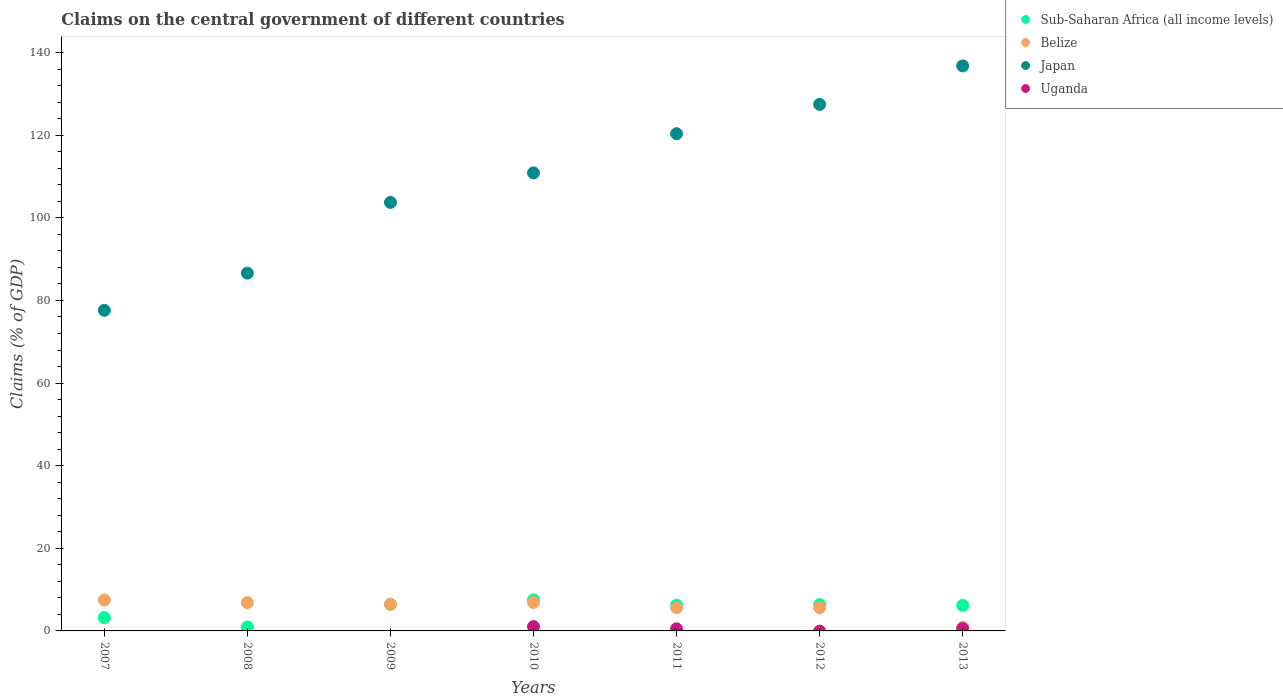How many different coloured dotlines are there?
Provide a succinct answer. 4. Is the number of dotlines equal to the number of legend labels?
Make the answer very short. No. What is the percentage of GDP claimed on the central government in Uganda in 2007?
Ensure brevity in your answer.  0. Across all years, what is the maximum percentage of GDP claimed on the central government in Sub-Saharan Africa (all income levels)?
Offer a terse response. 7.52. Across all years, what is the minimum percentage of GDP claimed on the central government in Japan?
Offer a very short reply. 77.62. What is the total percentage of GDP claimed on the central government in Sub-Saharan Africa (all income levels) in the graph?
Your answer should be very brief. 36.92. What is the difference between the percentage of GDP claimed on the central government in Belize in 2008 and that in 2011?
Provide a succinct answer. 1.26. What is the difference between the percentage of GDP claimed on the central government in Japan in 2008 and the percentage of GDP claimed on the central government in Belize in 2012?
Provide a succinct answer. 80.99. What is the average percentage of GDP claimed on the central government in Japan per year?
Keep it short and to the point. 109.07. In the year 2009, what is the difference between the percentage of GDP claimed on the central government in Japan and percentage of GDP claimed on the central government in Belize?
Offer a terse response. 97.32. In how many years, is the percentage of GDP claimed on the central government in Sub-Saharan Africa (all income levels) greater than 104 %?
Offer a terse response. 0. What is the ratio of the percentage of GDP claimed on the central government in Japan in 2007 to that in 2010?
Ensure brevity in your answer.  0.7. Is the difference between the percentage of GDP claimed on the central government in Japan in 2010 and 2012 greater than the difference between the percentage of GDP claimed on the central government in Belize in 2010 and 2012?
Make the answer very short. No. What is the difference between the highest and the second highest percentage of GDP claimed on the central government in Sub-Saharan Africa (all income levels)?
Offer a terse response. 1.07. What is the difference between the highest and the lowest percentage of GDP claimed on the central government in Uganda?
Provide a short and direct response. 1.07. Is the sum of the percentage of GDP claimed on the central government in Belize in 2009 and 2013 greater than the maximum percentage of GDP claimed on the central government in Sub-Saharan Africa (all income levels) across all years?
Keep it short and to the point. No. Is it the case that in every year, the sum of the percentage of GDP claimed on the central government in Belize and percentage of GDP claimed on the central government in Uganda  is greater than the percentage of GDP claimed on the central government in Sub-Saharan Africa (all income levels)?
Offer a terse response. No. Is the percentage of GDP claimed on the central government in Belize strictly greater than the percentage of GDP claimed on the central government in Sub-Saharan Africa (all income levels) over the years?
Provide a succinct answer. No. Is the percentage of GDP claimed on the central government in Belize strictly less than the percentage of GDP claimed on the central government in Sub-Saharan Africa (all income levels) over the years?
Your response must be concise. No. How many dotlines are there?
Your response must be concise. 4. What is the difference between two consecutive major ticks on the Y-axis?
Provide a succinct answer. 20. Are the values on the major ticks of Y-axis written in scientific E-notation?
Give a very brief answer. No. Where does the legend appear in the graph?
Keep it short and to the point. Top right. How many legend labels are there?
Offer a terse response. 4. What is the title of the graph?
Keep it short and to the point. Claims on the central government of different countries. Does "Moldova" appear as one of the legend labels in the graph?
Make the answer very short. No. What is the label or title of the X-axis?
Provide a short and direct response. Years. What is the label or title of the Y-axis?
Keep it short and to the point. Claims (% of GDP). What is the Claims (% of GDP) in Sub-Saharan Africa (all income levels) in 2007?
Your answer should be very brief. 3.22. What is the Claims (% of GDP) in Belize in 2007?
Give a very brief answer. 7.47. What is the Claims (% of GDP) in Japan in 2007?
Keep it short and to the point. 77.62. What is the Claims (% of GDP) in Sub-Saharan Africa (all income levels) in 2008?
Ensure brevity in your answer.  0.96. What is the Claims (% of GDP) of Belize in 2008?
Provide a short and direct response. 6.86. What is the Claims (% of GDP) in Japan in 2008?
Keep it short and to the point. 86.61. What is the Claims (% of GDP) in Sub-Saharan Africa (all income levels) in 2009?
Ensure brevity in your answer.  6.45. What is the Claims (% of GDP) of Belize in 2009?
Your answer should be compact. 6.42. What is the Claims (% of GDP) of Japan in 2009?
Provide a short and direct response. 103.74. What is the Claims (% of GDP) of Uganda in 2009?
Offer a very short reply. 0. What is the Claims (% of GDP) in Sub-Saharan Africa (all income levels) in 2010?
Your answer should be compact. 7.52. What is the Claims (% of GDP) in Belize in 2010?
Offer a very short reply. 6.9. What is the Claims (% of GDP) in Japan in 2010?
Provide a short and direct response. 110.89. What is the Claims (% of GDP) in Uganda in 2010?
Give a very brief answer. 1.07. What is the Claims (% of GDP) of Sub-Saharan Africa (all income levels) in 2011?
Provide a succinct answer. 6.23. What is the Claims (% of GDP) of Belize in 2011?
Ensure brevity in your answer.  5.6. What is the Claims (% of GDP) in Japan in 2011?
Provide a succinct answer. 120.37. What is the Claims (% of GDP) of Uganda in 2011?
Give a very brief answer. 0.51. What is the Claims (% of GDP) of Sub-Saharan Africa (all income levels) in 2012?
Your answer should be very brief. 6.37. What is the Claims (% of GDP) in Belize in 2012?
Your response must be concise. 5.63. What is the Claims (% of GDP) in Japan in 2012?
Provide a short and direct response. 127.47. What is the Claims (% of GDP) in Sub-Saharan Africa (all income levels) in 2013?
Your response must be concise. 6.17. What is the Claims (% of GDP) in Belize in 2013?
Ensure brevity in your answer.  0.89. What is the Claims (% of GDP) of Japan in 2013?
Keep it short and to the point. 136.79. What is the Claims (% of GDP) of Uganda in 2013?
Offer a very short reply. 0.54. Across all years, what is the maximum Claims (% of GDP) of Sub-Saharan Africa (all income levels)?
Your response must be concise. 7.52. Across all years, what is the maximum Claims (% of GDP) of Belize?
Your answer should be very brief. 7.47. Across all years, what is the maximum Claims (% of GDP) of Japan?
Give a very brief answer. 136.79. Across all years, what is the maximum Claims (% of GDP) of Uganda?
Your answer should be very brief. 1.07. Across all years, what is the minimum Claims (% of GDP) in Sub-Saharan Africa (all income levels)?
Ensure brevity in your answer.  0.96. Across all years, what is the minimum Claims (% of GDP) of Belize?
Your response must be concise. 0.89. Across all years, what is the minimum Claims (% of GDP) of Japan?
Your response must be concise. 77.62. Across all years, what is the minimum Claims (% of GDP) of Uganda?
Your response must be concise. 0. What is the total Claims (% of GDP) in Sub-Saharan Africa (all income levels) in the graph?
Offer a very short reply. 36.92. What is the total Claims (% of GDP) in Belize in the graph?
Offer a terse response. 39.76. What is the total Claims (% of GDP) in Japan in the graph?
Provide a succinct answer. 763.5. What is the total Claims (% of GDP) in Uganda in the graph?
Offer a very short reply. 2.12. What is the difference between the Claims (% of GDP) in Sub-Saharan Africa (all income levels) in 2007 and that in 2008?
Make the answer very short. 2.27. What is the difference between the Claims (% of GDP) in Belize in 2007 and that in 2008?
Make the answer very short. 0.62. What is the difference between the Claims (% of GDP) in Japan in 2007 and that in 2008?
Ensure brevity in your answer.  -8.99. What is the difference between the Claims (% of GDP) in Sub-Saharan Africa (all income levels) in 2007 and that in 2009?
Keep it short and to the point. -3.22. What is the difference between the Claims (% of GDP) of Belize in 2007 and that in 2009?
Your answer should be very brief. 1.06. What is the difference between the Claims (% of GDP) of Japan in 2007 and that in 2009?
Offer a very short reply. -26.12. What is the difference between the Claims (% of GDP) in Sub-Saharan Africa (all income levels) in 2007 and that in 2010?
Your answer should be compact. -4.3. What is the difference between the Claims (% of GDP) of Belize in 2007 and that in 2010?
Provide a short and direct response. 0.58. What is the difference between the Claims (% of GDP) in Japan in 2007 and that in 2010?
Offer a terse response. -33.27. What is the difference between the Claims (% of GDP) of Sub-Saharan Africa (all income levels) in 2007 and that in 2011?
Provide a short and direct response. -3. What is the difference between the Claims (% of GDP) of Belize in 2007 and that in 2011?
Offer a very short reply. 1.88. What is the difference between the Claims (% of GDP) in Japan in 2007 and that in 2011?
Provide a short and direct response. -42.75. What is the difference between the Claims (% of GDP) in Sub-Saharan Africa (all income levels) in 2007 and that in 2012?
Ensure brevity in your answer.  -3.15. What is the difference between the Claims (% of GDP) of Belize in 2007 and that in 2012?
Provide a succinct answer. 1.85. What is the difference between the Claims (% of GDP) of Japan in 2007 and that in 2012?
Offer a very short reply. -49.85. What is the difference between the Claims (% of GDP) in Sub-Saharan Africa (all income levels) in 2007 and that in 2013?
Offer a terse response. -2.94. What is the difference between the Claims (% of GDP) in Belize in 2007 and that in 2013?
Your answer should be compact. 6.59. What is the difference between the Claims (% of GDP) in Japan in 2007 and that in 2013?
Make the answer very short. -59.17. What is the difference between the Claims (% of GDP) of Sub-Saharan Africa (all income levels) in 2008 and that in 2009?
Offer a very short reply. -5.49. What is the difference between the Claims (% of GDP) of Belize in 2008 and that in 2009?
Ensure brevity in your answer.  0.44. What is the difference between the Claims (% of GDP) in Japan in 2008 and that in 2009?
Offer a very short reply. -17.13. What is the difference between the Claims (% of GDP) in Sub-Saharan Africa (all income levels) in 2008 and that in 2010?
Make the answer very short. -6.56. What is the difference between the Claims (% of GDP) in Belize in 2008 and that in 2010?
Your answer should be very brief. -0.04. What is the difference between the Claims (% of GDP) of Japan in 2008 and that in 2010?
Make the answer very short. -24.28. What is the difference between the Claims (% of GDP) in Sub-Saharan Africa (all income levels) in 2008 and that in 2011?
Provide a short and direct response. -5.27. What is the difference between the Claims (% of GDP) in Belize in 2008 and that in 2011?
Your answer should be very brief. 1.26. What is the difference between the Claims (% of GDP) of Japan in 2008 and that in 2011?
Make the answer very short. -33.75. What is the difference between the Claims (% of GDP) in Sub-Saharan Africa (all income levels) in 2008 and that in 2012?
Provide a short and direct response. -5.42. What is the difference between the Claims (% of GDP) of Belize in 2008 and that in 2012?
Your answer should be compact. 1.23. What is the difference between the Claims (% of GDP) in Japan in 2008 and that in 2012?
Keep it short and to the point. -40.86. What is the difference between the Claims (% of GDP) in Sub-Saharan Africa (all income levels) in 2008 and that in 2013?
Make the answer very short. -5.21. What is the difference between the Claims (% of GDP) in Belize in 2008 and that in 2013?
Offer a very short reply. 5.97. What is the difference between the Claims (% of GDP) in Japan in 2008 and that in 2013?
Offer a very short reply. -50.17. What is the difference between the Claims (% of GDP) of Sub-Saharan Africa (all income levels) in 2009 and that in 2010?
Ensure brevity in your answer.  -1.07. What is the difference between the Claims (% of GDP) in Belize in 2009 and that in 2010?
Keep it short and to the point. -0.48. What is the difference between the Claims (% of GDP) in Japan in 2009 and that in 2010?
Your answer should be very brief. -7.15. What is the difference between the Claims (% of GDP) of Sub-Saharan Africa (all income levels) in 2009 and that in 2011?
Your answer should be very brief. 0.22. What is the difference between the Claims (% of GDP) in Belize in 2009 and that in 2011?
Offer a terse response. 0.82. What is the difference between the Claims (% of GDP) in Japan in 2009 and that in 2011?
Provide a succinct answer. -16.63. What is the difference between the Claims (% of GDP) of Sub-Saharan Africa (all income levels) in 2009 and that in 2012?
Make the answer very short. 0.07. What is the difference between the Claims (% of GDP) in Belize in 2009 and that in 2012?
Offer a very short reply. 0.79. What is the difference between the Claims (% of GDP) in Japan in 2009 and that in 2012?
Give a very brief answer. -23.73. What is the difference between the Claims (% of GDP) of Sub-Saharan Africa (all income levels) in 2009 and that in 2013?
Your answer should be very brief. 0.28. What is the difference between the Claims (% of GDP) in Belize in 2009 and that in 2013?
Ensure brevity in your answer.  5.53. What is the difference between the Claims (% of GDP) in Japan in 2009 and that in 2013?
Offer a terse response. -33.05. What is the difference between the Claims (% of GDP) of Sub-Saharan Africa (all income levels) in 2010 and that in 2011?
Ensure brevity in your answer.  1.29. What is the difference between the Claims (% of GDP) in Belize in 2010 and that in 2011?
Your response must be concise. 1.3. What is the difference between the Claims (% of GDP) of Japan in 2010 and that in 2011?
Give a very brief answer. -9.47. What is the difference between the Claims (% of GDP) in Uganda in 2010 and that in 2011?
Ensure brevity in your answer.  0.56. What is the difference between the Claims (% of GDP) in Sub-Saharan Africa (all income levels) in 2010 and that in 2012?
Offer a very short reply. 1.15. What is the difference between the Claims (% of GDP) in Belize in 2010 and that in 2012?
Your response must be concise. 1.27. What is the difference between the Claims (% of GDP) of Japan in 2010 and that in 2012?
Provide a short and direct response. -16.58. What is the difference between the Claims (% of GDP) of Sub-Saharan Africa (all income levels) in 2010 and that in 2013?
Provide a succinct answer. 1.35. What is the difference between the Claims (% of GDP) in Belize in 2010 and that in 2013?
Ensure brevity in your answer.  6.01. What is the difference between the Claims (% of GDP) in Japan in 2010 and that in 2013?
Offer a very short reply. -25.89. What is the difference between the Claims (% of GDP) of Uganda in 2010 and that in 2013?
Provide a short and direct response. 0.53. What is the difference between the Claims (% of GDP) of Sub-Saharan Africa (all income levels) in 2011 and that in 2012?
Offer a terse response. -0.15. What is the difference between the Claims (% of GDP) of Belize in 2011 and that in 2012?
Ensure brevity in your answer.  -0.03. What is the difference between the Claims (% of GDP) of Japan in 2011 and that in 2012?
Provide a short and direct response. -7.11. What is the difference between the Claims (% of GDP) of Sub-Saharan Africa (all income levels) in 2011 and that in 2013?
Give a very brief answer. 0.06. What is the difference between the Claims (% of GDP) in Belize in 2011 and that in 2013?
Make the answer very short. 4.71. What is the difference between the Claims (% of GDP) of Japan in 2011 and that in 2013?
Ensure brevity in your answer.  -16.42. What is the difference between the Claims (% of GDP) of Uganda in 2011 and that in 2013?
Provide a succinct answer. -0.03. What is the difference between the Claims (% of GDP) of Sub-Saharan Africa (all income levels) in 2012 and that in 2013?
Offer a terse response. 0.21. What is the difference between the Claims (% of GDP) of Belize in 2012 and that in 2013?
Offer a terse response. 4.74. What is the difference between the Claims (% of GDP) in Japan in 2012 and that in 2013?
Offer a terse response. -9.31. What is the difference between the Claims (% of GDP) in Sub-Saharan Africa (all income levels) in 2007 and the Claims (% of GDP) in Belize in 2008?
Make the answer very short. -3.63. What is the difference between the Claims (% of GDP) of Sub-Saharan Africa (all income levels) in 2007 and the Claims (% of GDP) of Japan in 2008?
Offer a terse response. -83.39. What is the difference between the Claims (% of GDP) in Belize in 2007 and the Claims (% of GDP) in Japan in 2008?
Provide a succinct answer. -79.14. What is the difference between the Claims (% of GDP) in Sub-Saharan Africa (all income levels) in 2007 and the Claims (% of GDP) in Belize in 2009?
Provide a succinct answer. -3.19. What is the difference between the Claims (% of GDP) in Sub-Saharan Africa (all income levels) in 2007 and the Claims (% of GDP) in Japan in 2009?
Ensure brevity in your answer.  -100.52. What is the difference between the Claims (% of GDP) in Belize in 2007 and the Claims (% of GDP) in Japan in 2009?
Offer a very short reply. -96.26. What is the difference between the Claims (% of GDP) in Sub-Saharan Africa (all income levels) in 2007 and the Claims (% of GDP) in Belize in 2010?
Your response must be concise. -3.67. What is the difference between the Claims (% of GDP) in Sub-Saharan Africa (all income levels) in 2007 and the Claims (% of GDP) in Japan in 2010?
Offer a very short reply. -107.67. What is the difference between the Claims (% of GDP) of Sub-Saharan Africa (all income levels) in 2007 and the Claims (% of GDP) of Uganda in 2010?
Your answer should be compact. 2.16. What is the difference between the Claims (% of GDP) of Belize in 2007 and the Claims (% of GDP) of Japan in 2010?
Make the answer very short. -103.42. What is the difference between the Claims (% of GDP) of Belize in 2007 and the Claims (% of GDP) of Uganda in 2010?
Ensure brevity in your answer.  6.41. What is the difference between the Claims (% of GDP) of Japan in 2007 and the Claims (% of GDP) of Uganda in 2010?
Provide a short and direct response. 76.55. What is the difference between the Claims (% of GDP) in Sub-Saharan Africa (all income levels) in 2007 and the Claims (% of GDP) in Belize in 2011?
Make the answer very short. -2.38. What is the difference between the Claims (% of GDP) in Sub-Saharan Africa (all income levels) in 2007 and the Claims (% of GDP) in Japan in 2011?
Your response must be concise. -117.14. What is the difference between the Claims (% of GDP) of Sub-Saharan Africa (all income levels) in 2007 and the Claims (% of GDP) of Uganda in 2011?
Ensure brevity in your answer.  2.71. What is the difference between the Claims (% of GDP) in Belize in 2007 and the Claims (% of GDP) in Japan in 2011?
Keep it short and to the point. -112.89. What is the difference between the Claims (% of GDP) in Belize in 2007 and the Claims (% of GDP) in Uganda in 2011?
Offer a terse response. 6.97. What is the difference between the Claims (% of GDP) of Japan in 2007 and the Claims (% of GDP) of Uganda in 2011?
Your answer should be compact. 77.11. What is the difference between the Claims (% of GDP) in Sub-Saharan Africa (all income levels) in 2007 and the Claims (% of GDP) in Belize in 2012?
Make the answer very short. -2.4. What is the difference between the Claims (% of GDP) of Sub-Saharan Africa (all income levels) in 2007 and the Claims (% of GDP) of Japan in 2012?
Your answer should be very brief. -124.25. What is the difference between the Claims (% of GDP) in Belize in 2007 and the Claims (% of GDP) in Japan in 2012?
Provide a short and direct response. -120. What is the difference between the Claims (% of GDP) in Sub-Saharan Africa (all income levels) in 2007 and the Claims (% of GDP) in Belize in 2013?
Offer a terse response. 2.34. What is the difference between the Claims (% of GDP) in Sub-Saharan Africa (all income levels) in 2007 and the Claims (% of GDP) in Japan in 2013?
Offer a very short reply. -133.56. What is the difference between the Claims (% of GDP) in Sub-Saharan Africa (all income levels) in 2007 and the Claims (% of GDP) in Uganda in 2013?
Ensure brevity in your answer.  2.68. What is the difference between the Claims (% of GDP) in Belize in 2007 and the Claims (% of GDP) in Japan in 2013?
Make the answer very short. -129.31. What is the difference between the Claims (% of GDP) of Belize in 2007 and the Claims (% of GDP) of Uganda in 2013?
Provide a short and direct response. 6.93. What is the difference between the Claims (% of GDP) of Japan in 2007 and the Claims (% of GDP) of Uganda in 2013?
Offer a very short reply. 77.08. What is the difference between the Claims (% of GDP) in Sub-Saharan Africa (all income levels) in 2008 and the Claims (% of GDP) in Belize in 2009?
Offer a terse response. -5.46. What is the difference between the Claims (% of GDP) of Sub-Saharan Africa (all income levels) in 2008 and the Claims (% of GDP) of Japan in 2009?
Give a very brief answer. -102.78. What is the difference between the Claims (% of GDP) of Belize in 2008 and the Claims (% of GDP) of Japan in 2009?
Your response must be concise. -96.88. What is the difference between the Claims (% of GDP) in Sub-Saharan Africa (all income levels) in 2008 and the Claims (% of GDP) in Belize in 2010?
Your answer should be very brief. -5.94. What is the difference between the Claims (% of GDP) of Sub-Saharan Africa (all income levels) in 2008 and the Claims (% of GDP) of Japan in 2010?
Your answer should be compact. -109.94. What is the difference between the Claims (% of GDP) of Sub-Saharan Africa (all income levels) in 2008 and the Claims (% of GDP) of Uganda in 2010?
Give a very brief answer. -0.11. What is the difference between the Claims (% of GDP) in Belize in 2008 and the Claims (% of GDP) in Japan in 2010?
Make the answer very short. -104.04. What is the difference between the Claims (% of GDP) of Belize in 2008 and the Claims (% of GDP) of Uganda in 2010?
Provide a short and direct response. 5.79. What is the difference between the Claims (% of GDP) of Japan in 2008 and the Claims (% of GDP) of Uganda in 2010?
Your answer should be very brief. 85.55. What is the difference between the Claims (% of GDP) of Sub-Saharan Africa (all income levels) in 2008 and the Claims (% of GDP) of Belize in 2011?
Offer a terse response. -4.64. What is the difference between the Claims (% of GDP) of Sub-Saharan Africa (all income levels) in 2008 and the Claims (% of GDP) of Japan in 2011?
Offer a very short reply. -119.41. What is the difference between the Claims (% of GDP) in Sub-Saharan Africa (all income levels) in 2008 and the Claims (% of GDP) in Uganda in 2011?
Keep it short and to the point. 0.45. What is the difference between the Claims (% of GDP) in Belize in 2008 and the Claims (% of GDP) in Japan in 2011?
Offer a terse response. -113.51. What is the difference between the Claims (% of GDP) in Belize in 2008 and the Claims (% of GDP) in Uganda in 2011?
Your response must be concise. 6.35. What is the difference between the Claims (% of GDP) of Japan in 2008 and the Claims (% of GDP) of Uganda in 2011?
Your answer should be very brief. 86.11. What is the difference between the Claims (% of GDP) of Sub-Saharan Africa (all income levels) in 2008 and the Claims (% of GDP) of Belize in 2012?
Offer a terse response. -4.67. What is the difference between the Claims (% of GDP) in Sub-Saharan Africa (all income levels) in 2008 and the Claims (% of GDP) in Japan in 2012?
Ensure brevity in your answer.  -126.52. What is the difference between the Claims (% of GDP) in Belize in 2008 and the Claims (% of GDP) in Japan in 2012?
Offer a terse response. -120.62. What is the difference between the Claims (% of GDP) of Sub-Saharan Africa (all income levels) in 2008 and the Claims (% of GDP) of Belize in 2013?
Provide a succinct answer. 0.07. What is the difference between the Claims (% of GDP) of Sub-Saharan Africa (all income levels) in 2008 and the Claims (% of GDP) of Japan in 2013?
Your answer should be compact. -135.83. What is the difference between the Claims (% of GDP) of Sub-Saharan Africa (all income levels) in 2008 and the Claims (% of GDP) of Uganda in 2013?
Keep it short and to the point. 0.42. What is the difference between the Claims (% of GDP) of Belize in 2008 and the Claims (% of GDP) of Japan in 2013?
Offer a terse response. -129.93. What is the difference between the Claims (% of GDP) of Belize in 2008 and the Claims (% of GDP) of Uganda in 2013?
Your answer should be very brief. 6.32. What is the difference between the Claims (% of GDP) of Japan in 2008 and the Claims (% of GDP) of Uganda in 2013?
Offer a very short reply. 86.07. What is the difference between the Claims (% of GDP) of Sub-Saharan Africa (all income levels) in 2009 and the Claims (% of GDP) of Belize in 2010?
Your answer should be compact. -0.45. What is the difference between the Claims (% of GDP) of Sub-Saharan Africa (all income levels) in 2009 and the Claims (% of GDP) of Japan in 2010?
Offer a terse response. -104.45. What is the difference between the Claims (% of GDP) of Sub-Saharan Africa (all income levels) in 2009 and the Claims (% of GDP) of Uganda in 2010?
Give a very brief answer. 5.38. What is the difference between the Claims (% of GDP) of Belize in 2009 and the Claims (% of GDP) of Japan in 2010?
Offer a terse response. -104.48. What is the difference between the Claims (% of GDP) of Belize in 2009 and the Claims (% of GDP) of Uganda in 2010?
Your response must be concise. 5.35. What is the difference between the Claims (% of GDP) in Japan in 2009 and the Claims (% of GDP) in Uganda in 2010?
Keep it short and to the point. 102.67. What is the difference between the Claims (% of GDP) of Sub-Saharan Africa (all income levels) in 2009 and the Claims (% of GDP) of Belize in 2011?
Keep it short and to the point. 0.85. What is the difference between the Claims (% of GDP) in Sub-Saharan Africa (all income levels) in 2009 and the Claims (% of GDP) in Japan in 2011?
Offer a very short reply. -113.92. What is the difference between the Claims (% of GDP) in Sub-Saharan Africa (all income levels) in 2009 and the Claims (% of GDP) in Uganda in 2011?
Offer a terse response. 5.94. What is the difference between the Claims (% of GDP) in Belize in 2009 and the Claims (% of GDP) in Japan in 2011?
Make the answer very short. -113.95. What is the difference between the Claims (% of GDP) of Belize in 2009 and the Claims (% of GDP) of Uganda in 2011?
Your response must be concise. 5.91. What is the difference between the Claims (% of GDP) in Japan in 2009 and the Claims (% of GDP) in Uganda in 2011?
Provide a short and direct response. 103.23. What is the difference between the Claims (% of GDP) of Sub-Saharan Africa (all income levels) in 2009 and the Claims (% of GDP) of Belize in 2012?
Make the answer very short. 0.82. What is the difference between the Claims (% of GDP) in Sub-Saharan Africa (all income levels) in 2009 and the Claims (% of GDP) in Japan in 2012?
Keep it short and to the point. -121.03. What is the difference between the Claims (% of GDP) of Belize in 2009 and the Claims (% of GDP) of Japan in 2012?
Provide a succinct answer. -121.06. What is the difference between the Claims (% of GDP) in Sub-Saharan Africa (all income levels) in 2009 and the Claims (% of GDP) in Belize in 2013?
Give a very brief answer. 5.56. What is the difference between the Claims (% of GDP) of Sub-Saharan Africa (all income levels) in 2009 and the Claims (% of GDP) of Japan in 2013?
Ensure brevity in your answer.  -130.34. What is the difference between the Claims (% of GDP) of Sub-Saharan Africa (all income levels) in 2009 and the Claims (% of GDP) of Uganda in 2013?
Offer a terse response. 5.91. What is the difference between the Claims (% of GDP) of Belize in 2009 and the Claims (% of GDP) of Japan in 2013?
Provide a succinct answer. -130.37. What is the difference between the Claims (% of GDP) in Belize in 2009 and the Claims (% of GDP) in Uganda in 2013?
Give a very brief answer. 5.87. What is the difference between the Claims (% of GDP) of Japan in 2009 and the Claims (% of GDP) of Uganda in 2013?
Your response must be concise. 103.2. What is the difference between the Claims (% of GDP) of Sub-Saharan Africa (all income levels) in 2010 and the Claims (% of GDP) of Belize in 2011?
Offer a very short reply. 1.92. What is the difference between the Claims (% of GDP) in Sub-Saharan Africa (all income levels) in 2010 and the Claims (% of GDP) in Japan in 2011?
Ensure brevity in your answer.  -112.85. What is the difference between the Claims (% of GDP) in Sub-Saharan Africa (all income levels) in 2010 and the Claims (% of GDP) in Uganda in 2011?
Keep it short and to the point. 7.01. What is the difference between the Claims (% of GDP) in Belize in 2010 and the Claims (% of GDP) in Japan in 2011?
Your answer should be very brief. -113.47. What is the difference between the Claims (% of GDP) in Belize in 2010 and the Claims (% of GDP) in Uganda in 2011?
Your answer should be compact. 6.39. What is the difference between the Claims (% of GDP) in Japan in 2010 and the Claims (% of GDP) in Uganda in 2011?
Offer a terse response. 110.39. What is the difference between the Claims (% of GDP) of Sub-Saharan Africa (all income levels) in 2010 and the Claims (% of GDP) of Belize in 2012?
Keep it short and to the point. 1.9. What is the difference between the Claims (% of GDP) in Sub-Saharan Africa (all income levels) in 2010 and the Claims (% of GDP) in Japan in 2012?
Ensure brevity in your answer.  -119.95. What is the difference between the Claims (% of GDP) of Belize in 2010 and the Claims (% of GDP) of Japan in 2012?
Keep it short and to the point. -120.58. What is the difference between the Claims (% of GDP) in Sub-Saharan Africa (all income levels) in 2010 and the Claims (% of GDP) in Belize in 2013?
Your answer should be compact. 6.63. What is the difference between the Claims (% of GDP) in Sub-Saharan Africa (all income levels) in 2010 and the Claims (% of GDP) in Japan in 2013?
Provide a short and direct response. -129.27. What is the difference between the Claims (% of GDP) in Sub-Saharan Africa (all income levels) in 2010 and the Claims (% of GDP) in Uganda in 2013?
Offer a very short reply. 6.98. What is the difference between the Claims (% of GDP) of Belize in 2010 and the Claims (% of GDP) of Japan in 2013?
Keep it short and to the point. -129.89. What is the difference between the Claims (% of GDP) in Belize in 2010 and the Claims (% of GDP) in Uganda in 2013?
Provide a succinct answer. 6.35. What is the difference between the Claims (% of GDP) of Japan in 2010 and the Claims (% of GDP) of Uganda in 2013?
Make the answer very short. 110.35. What is the difference between the Claims (% of GDP) of Sub-Saharan Africa (all income levels) in 2011 and the Claims (% of GDP) of Belize in 2012?
Your answer should be very brief. 0.6. What is the difference between the Claims (% of GDP) of Sub-Saharan Africa (all income levels) in 2011 and the Claims (% of GDP) of Japan in 2012?
Provide a succinct answer. -121.25. What is the difference between the Claims (% of GDP) of Belize in 2011 and the Claims (% of GDP) of Japan in 2012?
Your response must be concise. -121.87. What is the difference between the Claims (% of GDP) in Sub-Saharan Africa (all income levels) in 2011 and the Claims (% of GDP) in Belize in 2013?
Make the answer very short. 5.34. What is the difference between the Claims (% of GDP) in Sub-Saharan Africa (all income levels) in 2011 and the Claims (% of GDP) in Japan in 2013?
Your answer should be compact. -130.56. What is the difference between the Claims (% of GDP) of Sub-Saharan Africa (all income levels) in 2011 and the Claims (% of GDP) of Uganda in 2013?
Your answer should be compact. 5.69. What is the difference between the Claims (% of GDP) of Belize in 2011 and the Claims (% of GDP) of Japan in 2013?
Your answer should be very brief. -131.19. What is the difference between the Claims (% of GDP) in Belize in 2011 and the Claims (% of GDP) in Uganda in 2013?
Keep it short and to the point. 5.06. What is the difference between the Claims (% of GDP) in Japan in 2011 and the Claims (% of GDP) in Uganda in 2013?
Offer a very short reply. 119.83. What is the difference between the Claims (% of GDP) in Sub-Saharan Africa (all income levels) in 2012 and the Claims (% of GDP) in Belize in 2013?
Your answer should be very brief. 5.49. What is the difference between the Claims (% of GDP) in Sub-Saharan Africa (all income levels) in 2012 and the Claims (% of GDP) in Japan in 2013?
Provide a short and direct response. -130.41. What is the difference between the Claims (% of GDP) of Sub-Saharan Africa (all income levels) in 2012 and the Claims (% of GDP) of Uganda in 2013?
Your answer should be compact. 5.83. What is the difference between the Claims (% of GDP) in Belize in 2012 and the Claims (% of GDP) in Japan in 2013?
Ensure brevity in your answer.  -131.16. What is the difference between the Claims (% of GDP) in Belize in 2012 and the Claims (% of GDP) in Uganda in 2013?
Provide a short and direct response. 5.08. What is the difference between the Claims (% of GDP) in Japan in 2012 and the Claims (% of GDP) in Uganda in 2013?
Your answer should be very brief. 126.93. What is the average Claims (% of GDP) in Sub-Saharan Africa (all income levels) per year?
Your response must be concise. 5.27. What is the average Claims (% of GDP) in Belize per year?
Keep it short and to the point. 5.68. What is the average Claims (% of GDP) of Japan per year?
Provide a short and direct response. 109.07. What is the average Claims (% of GDP) in Uganda per year?
Keep it short and to the point. 0.3. In the year 2007, what is the difference between the Claims (% of GDP) of Sub-Saharan Africa (all income levels) and Claims (% of GDP) of Belize?
Provide a short and direct response. -4.25. In the year 2007, what is the difference between the Claims (% of GDP) of Sub-Saharan Africa (all income levels) and Claims (% of GDP) of Japan?
Keep it short and to the point. -74.4. In the year 2007, what is the difference between the Claims (% of GDP) in Belize and Claims (% of GDP) in Japan?
Give a very brief answer. -70.15. In the year 2008, what is the difference between the Claims (% of GDP) in Sub-Saharan Africa (all income levels) and Claims (% of GDP) in Belize?
Offer a very short reply. -5.9. In the year 2008, what is the difference between the Claims (% of GDP) in Sub-Saharan Africa (all income levels) and Claims (% of GDP) in Japan?
Offer a very short reply. -85.66. In the year 2008, what is the difference between the Claims (% of GDP) in Belize and Claims (% of GDP) in Japan?
Give a very brief answer. -79.76. In the year 2009, what is the difference between the Claims (% of GDP) in Sub-Saharan Africa (all income levels) and Claims (% of GDP) in Belize?
Your answer should be compact. 0.03. In the year 2009, what is the difference between the Claims (% of GDP) of Sub-Saharan Africa (all income levels) and Claims (% of GDP) of Japan?
Offer a terse response. -97.29. In the year 2009, what is the difference between the Claims (% of GDP) of Belize and Claims (% of GDP) of Japan?
Your answer should be compact. -97.32. In the year 2010, what is the difference between the Claims (% of GDP) of Sub-Saharan Africa (all income levels) and Claims (% of GDP) of Belize?
Offer a terse response. 0.63. In the year 2010, what is the difference between the Claims (% of GDP) in Sub-Saharan Africa (all income levels) and Claims (% of GDP) in Japan?
Provide a short and direct response. -103.37. In the year 2010, what is the difference between the Claims (% of GDP) in Sub-Saharan Africa (all income levels) and Claims (% of GDP) in Uganda?
Give a very brief answer. 6.45. In the year 2010, what is the difference between the Claims (% of GDP) of Belize and Claims (% of GDP) of Japan?
Your answer should be very brief. -104. In the year 2010, what is the difference between the Claims (% of GDP) in Belize and Claims (% of GDP) in Uganda?
Provide a short and direct response. 5.83. In the year 2010, what is the difference between the Claims (% of GDP) of Japan and Claims (% of GDP) of Uganda?
Offer a terse response. 109.83. In the year 2011, what is the difference between the Claims (% of GDP) in Sub-Saharan Africa (all income levels) and Claims (% of GDP) in Belize?
Offer a very short reply. 0.63. In the year 2011, what is the difference between the Claims (% of GDP) of Sub-Saharan Africa (all income levels) and Claims (% of GDP) of Japan?
Your response must be concise. -114.14. In the year 2011, what is the difference between the Claims (% of GDP) of Sub-Saharan Africa (all income levels) and Claims (% of GDP) of Uganda?
Your response must be concise. 5.72. In the year 2011, what is the difference between the Claims (% of GDP) of Belize and Claims (% of GDP) of Japan?
Offer a very short reply. -114.77. In the year 2011, what is the difference between the Claims (% of GDP) in Belize and Claims (% of GDP) in Uganda?
Offer a very short reply. 5.09. In the year 2011, what is the difference between the Claims (% of GDP) of Japan and Claims (% of GDP) of Uganda?
Your response must be concise. 119.86. In the year 2012, what is the difference between the Claims (% of GDP) in Sub-Saharan Africa (all income levels) and Claims (% of GDP) in Belize?
Ensure brevity in your answer.  0.75. In the year 2012, what is the difference between the Claims (% of GDP) of Sub-Saharan Africa (all income levels) and Claims (% of GDP) of Japan?
Keep it short and to the point. -121.1. In the year 2012, what is the difference between the Claims (% of GDP) in Belize and Claims (% of GDP) in Japan?
Your answer should be compact. -121.85. In the year 2013, what is the difference between the Claims (% of GDP) of Sub-Saharan Africa (all income levels) and Claims (% of GDP) of Belize?
Your answer should be compact. 5.28. In the year 2013, what is the difference between the Claims (% of GDP) in Sub-Saharan Africa (all income levels) and Claims (% of GDP) in Japan?
Offer a very short reply. -130.62. In the year 2013, what is the difference between the Claims (% of GDP) in Sub-Saharan Africa (all income levels) and Claims (% of GDP) in Uganda?
Provide a short and direct response. 5.63. In the year 2013, what is the difference between the Claims (% of GDP) in Belize and Claims (% of GDP) in Japan?
Give a very brief answer. -135.9. In the year 2013, what is the difference between the Claims (% of GDP) of Belize and Claims (% of GDP) of Uganda?
Your response must be concise. 0.35. In the year 2013, what is the difference between the Claims (% of GDP) of Japan and Claims (% of GDP) of Uganda?
Make the answer very short. 136.25. What is the ratio of the Claims (% of GDP) of Sub-Saharan Africa (all income levels) in 2007 to that in 2008?
Your answer should be very brief. 3.37. What is the ratio of the Claims (% of GDP) of Belize in 2007 to that in 2008?
Ensure brevity in your answer.  1.09. What is the ratio of the Claims (% of GDP) of Japan in 2007 to that in 2008?
Keep it short and to the point. 0.9. What is the ratio of the Claims (% of GDP) in Sub-Saharan Africa (all income levels) in 2007 to that in 2009?
Provide a succinct answer. 0.5. What is the ratio of the Claims (% of GDP) in Belize in 2007 to that in 2009?
Keep it short and to the point. 1.17. What is the ratio of the Claims (% of GDP) of Japan in 2007 to that in 2009?
Provide a succinct answer. 0.75. What is the ratio of the Claims (% of GDP) of Sub-Saharan Africa (all income levels) in 2007 to that in 2010?
Give a very brief answer. 0.43. What is the ratio of the Claims (% of GDP) in Belize in 2007 to that in 2010?
Your answer should be compact. 1.08. What is the ratio of the Claims (% of GDP) of Japan in 2007 to that in 2010?
Your response must be concise. 0.7. What is the ratio of the Claims (% of GDP) in Sub-Saharan Africa (all income levels) in 2007 to that in 2011?
Offer a terse response. 0.52. What is the ratio of the Claims (% of GDP) of Belize in 2007 to that in 2011?
Ensure brevity in your answer.  1.33. What is the ratio of the Claims (% of GDP) of Japan in 2007 to that in 2011?
Make the answer very short. 0.64. What is the ratio of the Claims (% of GDP) of Sub-Saharan Africa (all income levels) in 2007 to that in 2012?
Your response must be concise. 0.51. What is the ratio of the Claims (% of GDP) in Belize in 2007 to that in 2012?
Ensure brevity in your answer.  1.33. What is the ratio of the Claims (% of GDP) of Japan in 2007 to that in 2012?
Your answer should be compact. 0.61. What is the ratio of the Claims (% of GDP) in Sub-Saharan Africa (all income levels) in 2007 to that in 2013?
Make the answer very short. 0.52. What is the ratio of the Claims (% of GDP) of Belize in 2007 to that in 2013?
Make the answer very short. 8.42. What is the ratio of the Claims (% of GDP) of Japan in 2007 to that in 2013?
Offer a very short reply. 0.57. What is the ratio of the Claims (% of GDP) in Sub-Saharan Africa (all income levels) in 2008 to that in 2009?
Your answer should be compact. 0.15. What is the ratio of the Claims (% of GDP) of Belize in 2008 to that in 2009?
Provide a succinct answer. 1.07. What is the ratio of the Claims (% of GDP) of Japan in 2008 to that in 2009?
Keep it short and to the point. 0.83. What is the ratio of the Claims (% of GDP) of Sub-Saharan Africa (all income levels) in 2008 to that in 2010?
Your response must be concise. 0.13. What is the ratio of the Claims (% of GDP) of Japan in 2008 to that in 2010?
Offer a terse response. 0.78. What is the ratio of the Claims (% of GDP) of Sub-Saharan Africa (all income levels) in 2008 to that in 2011?
Your answer should be very brief. 0.15. What is the ratio of the Claims (% of GDP) in Belize in 2008 to that in 2011?
Your answer should be very brief. 1.22. What is the ratio of the Claims (% of GDP) in Japan in 2008 to that in 2011?
Your response must be concise. 0.72. What is the ratio of the Claims (% of GDP) of Sub-Saharan Africa (all income levels) in 2008 to that in 2012?
Ensure brevity in your answer.  0.15. What is the ratio of the Claims (% of GDP) in Belize in 2008 to that in 2012?
Your response must be concise. 1.22. What is the ratio of the Claims (% of GDP) in Japan in 2008 to that in 2012?
Offer a terse response. 0.68. What is the ratio of the Claims (% of GDP) of Sub-Saharan Africa (all income levels) in 2008 to that in 2013?
Ensure brevity in your answer.  0.16. What is the ratio of the Claims (% of GDP) in Belize in 2008 to that in 2013?
Your answer should be very brief. 7.72. What is the ratio of the Claims (% of GDP) of Japan in 2008 to that in 2013?
Your answer should be compact. 0.63. What is the ratio of the Claims (% of GDP) of Sub-Saharan Africa (all income levels) in 2009 to that in 2010?
Give a very brief answer. 0.86. What is the ratio of the Claims (% of GDP) of Belize in 2009 to that in 2010?
Give a very brief answer. 0.93. What is the ratio of the Claims (% of GDP) of Japan in 2009 to that in 2010?
Keep it short and to the point. 0.94. What is the ratio of the Claims (% of GDP) of Sub-Saharan Africa (all income levels) in 2009 to that in 2011?
Make the answer very short. 1.04. What is the ratio of the Claims (% of GDP) in Belize in 2009 to that in 2011?
Your answer should be very brief. 1.15. What is the ratio of the Claims (% of GDP) in Japan in 2009 to that in 2011?
Ensure brevity in your answer.  0.86. What is the ratio of the Claims (% of GDP) in Sub-Saharan Africa (all income levels) in 2009 to that in 2012?
Offer a very short reply. 1.01. What is the ratio of the Claims (% of GDP) of Belize in 2009 to that in 2012?
Your answer should be very brief. 1.14. What is the ratio of the Claims (% of GDP) in Japan in 2009 to that in 2012?
Offer a very short reply. 0.81. What is the ratio of the Claims (% of GDP) of Sub-Saharan Africa (all income levels) in 2009 to that in 2013?
Make the answer very short. 1.05. What is the ratio of the Claims (% of GDP) in Belize in 2009 to that in 2013?
Your response must be concise. 7.23. What is the ratio of the Claims (% of GDP) in Japan in 2009 to that in 2013?
Your answer should be very brief. 0.76. What is the ratio of the Claims (% of GDP) in Sub-Saharan Africa (all income levels) in 2010 to that in 2011?
Your answer should be compact. 1.21. What is the ratio of the Claims (% of GDP) of Belize in 2010 to that in 2011?
Your answer should be compact. 1.23. What is the ratio of the Claims (% of GDP) in Japan in 2010 to that in 2011?
Your answer should be compact. 0.92. What is the ratio of the Claims (% of GDP) in Uganda in 2010 to that in 2011?
Your response must be concise. 2.1. What is the ratio of the Claims (% of GDP) in Sub-Saharan Africa (all income levels) in 2010 to that in 2012?
Your answer should be compact. 1.18. What is the ratio of the Claims (% of GDP) in Belize in 2010 to that in 2012?
Your response must be concise. 1.23. What is the ratio of the Claims (% of GDP) in Japan in 2010 to that in 2012?
Your response must be concise. 0.87. What is the ratio of the Claims (% of GDP) in Sub-Saharan Africa (all income levels) in 2010 to that in 2013?
Offer a very short reply. 1.22. What is the ratio of the Claims (% of GDP) of Belize in 2010 to that in 2013?
Ensure brevity in your answer.  7.77. What is the ratio of the Claims (% of GDP) of Japan in 2010 to that in 2013?
Offer a terse response. 0.81. What is the ratio of the Claims (% of GDP) in Uganda in 2010 to that in 2013?
Make the answer very short. 1.97. What is the ratio of the Claims (% of GDP) of Sub-Saharan Africa (all income levels) in 2011 to that in 2012?
Provide a short and direct response. 0.98. What is the ratio of the Claims (% of GDP) of Japan in 2011 to that in 2012?
Offer a terse response. 0.94. What is the ratio of the Claims (% of GDP) in Sub-Saharan Africa (all income levels) in 2011 to that in 2013?
Provide a short and direct response. 1.01. What is the ratio of the Claims (% of GDP) in Belize in 2011 to that in 2013?
Provide a succinct answer. 6.31. What is the ratio of the Claims (% of GDP) in Uganda in 2011 to that in 2013?
Offer a very short reply. 0.94. What is the ratio of the Claims (% of GDP) of Sub-Saharan Africa (all income levels) in 2012 to that in 2013?
Your answer should be very brief. 1.03. What is the ratio of the Claims (% of GDP) of Belize in 2012 to that in 2013?
Keep it short and to the point. 6.34. What is the ratio of the Claims (% of GDP) of Japan in 2012 to that in 2013?
Give a very brief answer. 0.93. What is the difference between the highest and the second highest Claims (% of GDP) in Sub-Saharan Africa (all income levels)?
Offer a very short reply. 1.07. What is the difference between the highest and the second highest Claims (% of GDP) in Belize?
Offer a terse response. 0.58. What is the difference between the highest and the second highest Claims (% of GDP) of Japan?
Provide a short and direct response. 9.31. What is the difference between the highest and the second highest Claims (% of GDP) of Uganda?
Give a very brief answer. 0.53. What is the difference between the highest and the lowest Claims (% of GDP) in Sub-Saharan Africa (all income levels)?
Provide a short and direct response. 6.56. What is the difference between the highest and the lowest Claims (% of GDP) in Belize?
Keep it short and to the point. 6.59. What is the difference between the highest and the lowest Claims (% of GDP) in Japan?
Make the answer very short. 59.17. What is the difference between the highest and the lowest Claims (% of GDP) of Uganda?
Your answer should be compact. 1.07. 